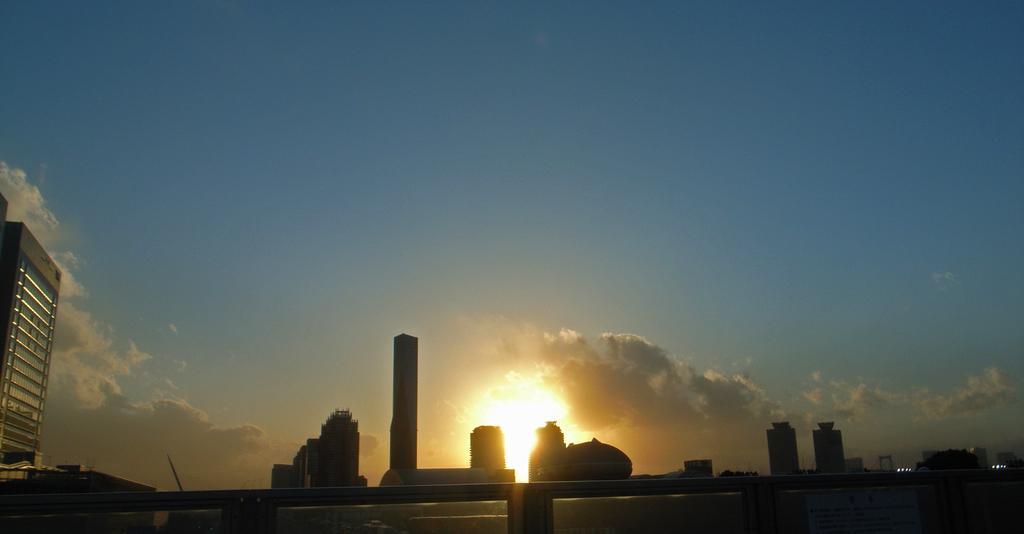In one or two sentences, can you explain what this image depicts? On the left side there is a building. Also there are many other buildings. In the back there is sky with clouds and sun is also there. 